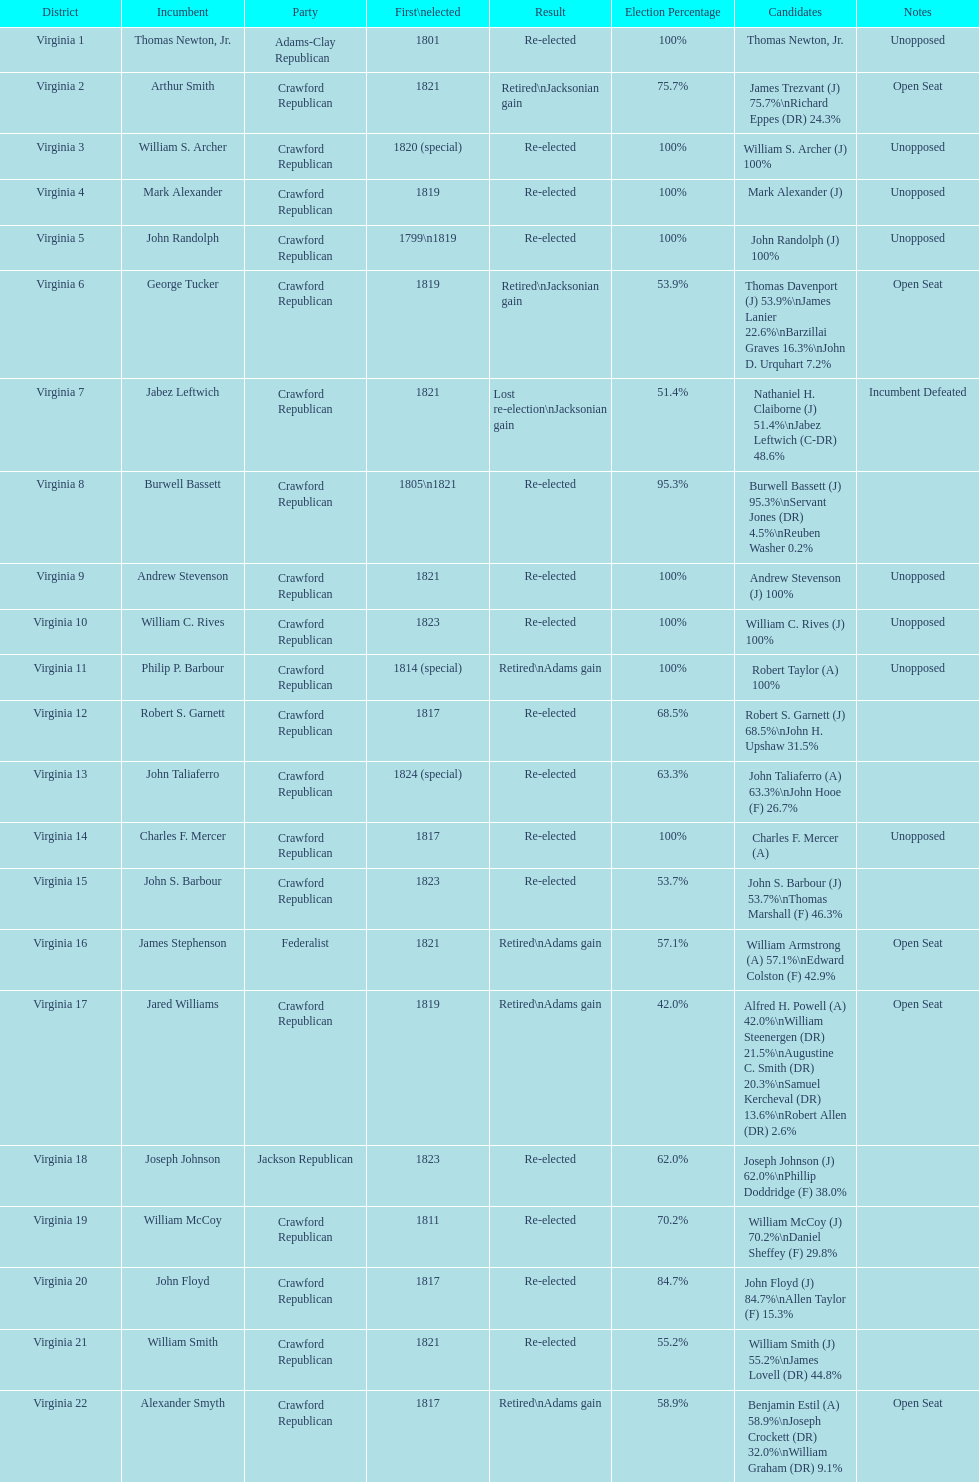What are the number of times re-elected is listed as the result? 15. 